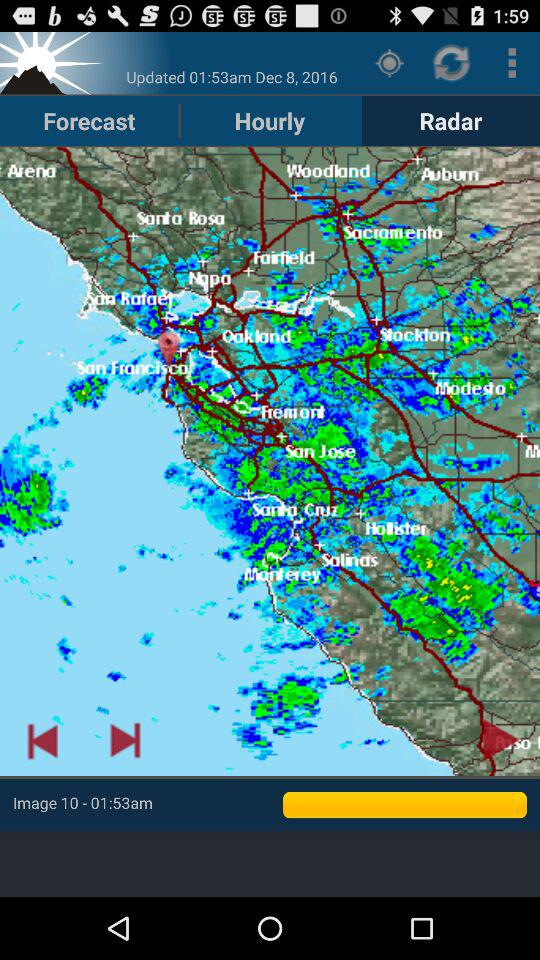Which tab am I on? You are on the "Radar" tab. 